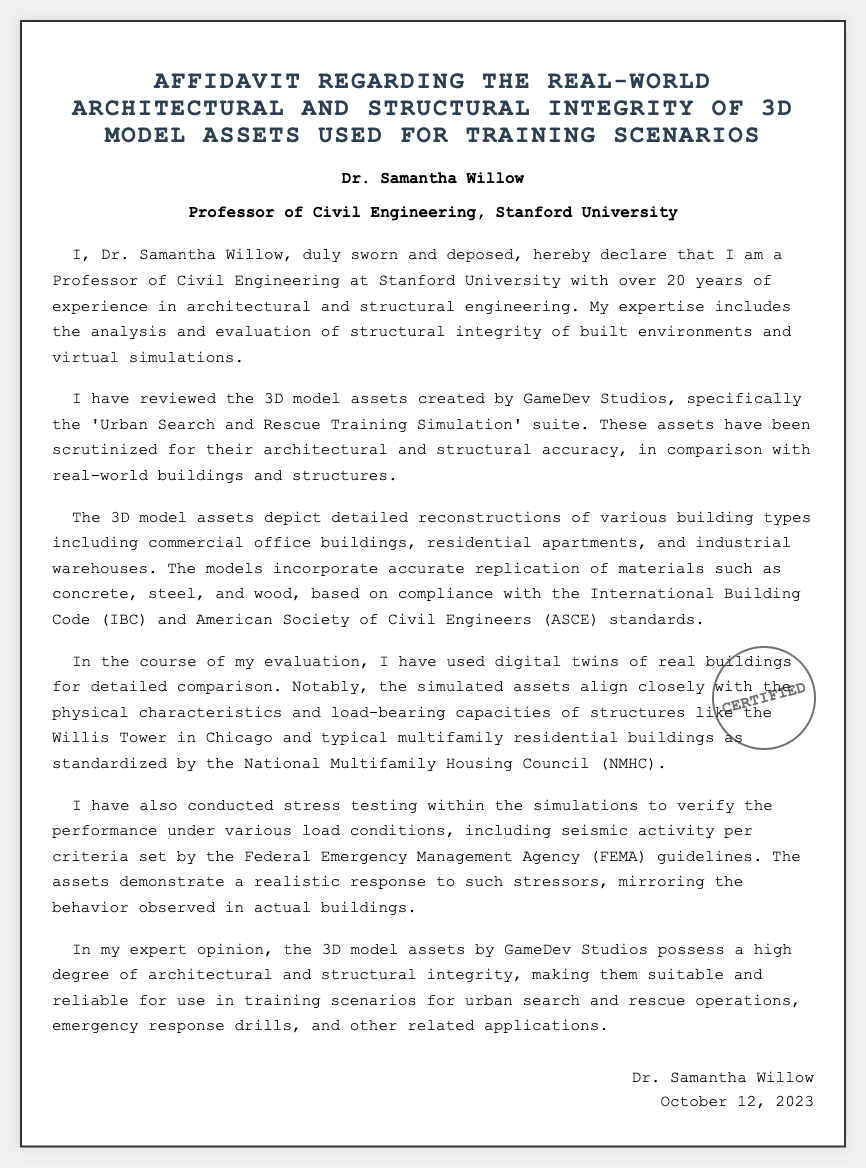What is the name of the affiant? The name of the affiant is mentioned at the beginning of the document.
Answer: Dr. Samantha Willow What is the profession of the affiant? The document clearly states the affiant's profession.
Answer: Professor of Civil Engineering What institution is the affiant affiliated with? The affiant's affiliated institution is noted within the opening section.
Answer: Stanford University When was the affidavit signed? The date of signing is included at the end of the document.
Answer: October 12, 2023 Which 3D model asset suite is reviewed? The specific asset suite reviewed by the affiant is stated in the document.
Answer: Urban Search and Rescue Training Simulation What standards were the models synthesized to comply with? The applicable standards mentioned in the affidavit provide insight into regulatory compliance.
Answer: International Building Code and American Society of Civil Engineers What type of structures do the 3D models depict? The affidavit lists the types of structures included in the 3D models.
Answer: Commercial office buildings, residential apartments, and industrial warehouses What performance testing was conducted within the simulations? The document describes the type of testing performed to assess the assets' response.
Answer: Stress testing What criteria guidance did the affiant use for seismic activity? The criteria for seismic activity used during evaluation is stated.
Answer: Federal Emergency Management Agency guidelines What is the affiant's overall opinion of the 3D model assets? The closing statement provides the affiant's overall assessment of the 3D model assets.
Answer: High degree of architectural and structural integrity 